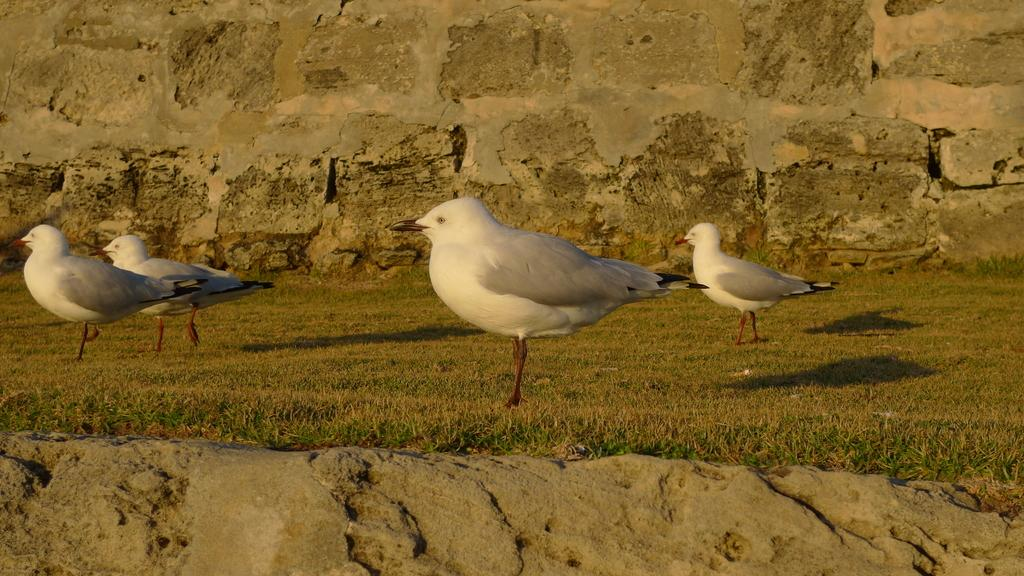What type of animals can be seen in the image? There are birds in the image. Where are the birds located in the image? The birds are standing on the ground. What is the ground covered with in the image? The ground is covered with grass. What type of net is being used to catch the birds in the image? There is no net present in the image, and the birds are not being caught. 